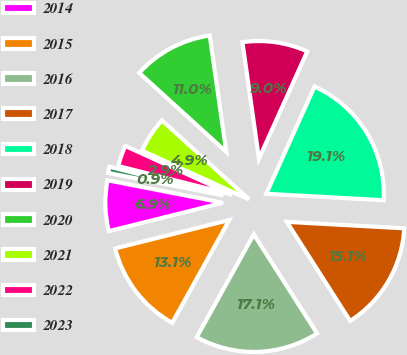Convert chart. <chart><loc_0><loc_0><loc_500><loc_500><pie_chart><fcel>2014<fcel>2015<fcel>2016<fcel>2017<fcel>2018<fcel>2019<fcel>2020<fcel>2021<fcel>2022<fcel>2023<nl><fcel>6.95%<fcel>13.05%<fcel>17.11%<fcel>15.08%<fcel>19.14%<fcel>8.98%<fcel>11.02%<fcel>4.92%<fcel>2.89%<fcel>0.86%<nl></chart> 